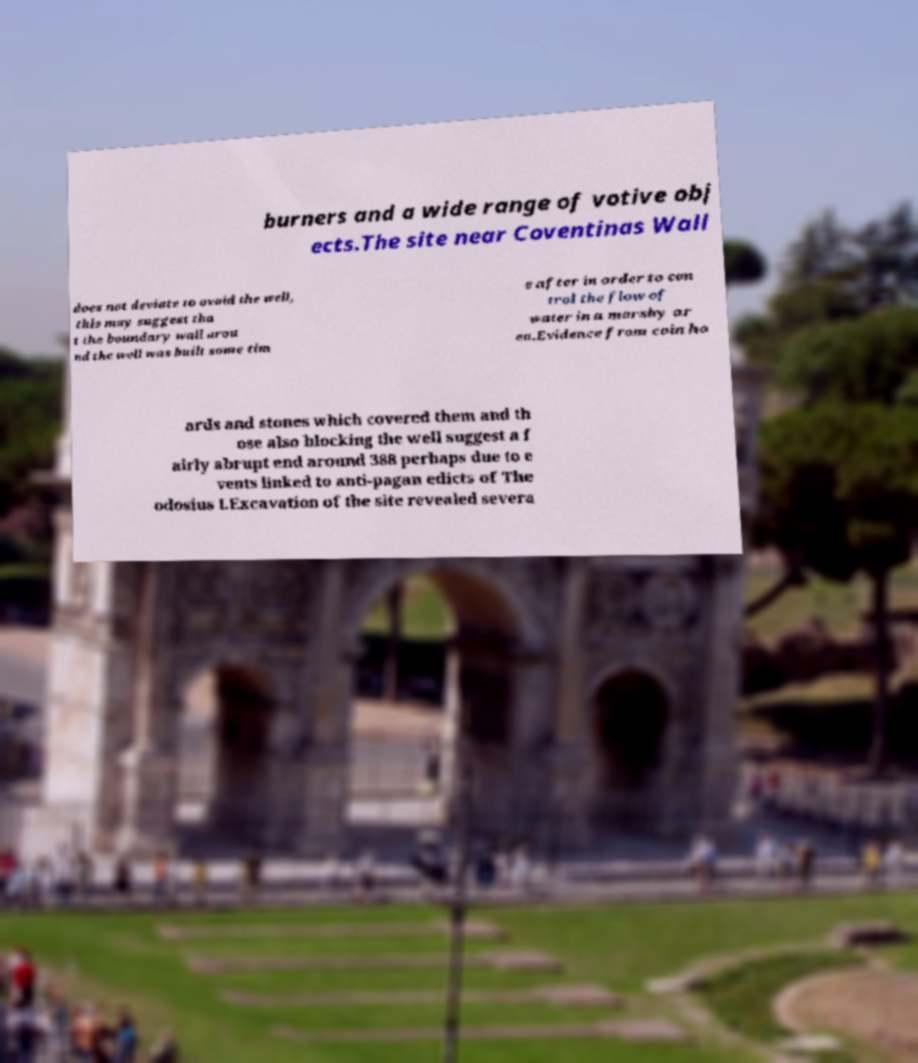Can you accurately transcribe the text from the provided image for me? burners and a wide range of votive obj ects.The site near Coventinas Wall does not deviate to avoid the well, this may suggest tha t the boundary wall arou nd the well was built some tim e after in order to con trol the flow of water in a marshy ar ea.Evidence from coin ho ards and stones which covered them and th ose also blocking the well suggest a f airly abrupt end around 388 perhaps due to e vents linked to anti-pagan edicts of The odosius I.Excavation of the site revealed severa 